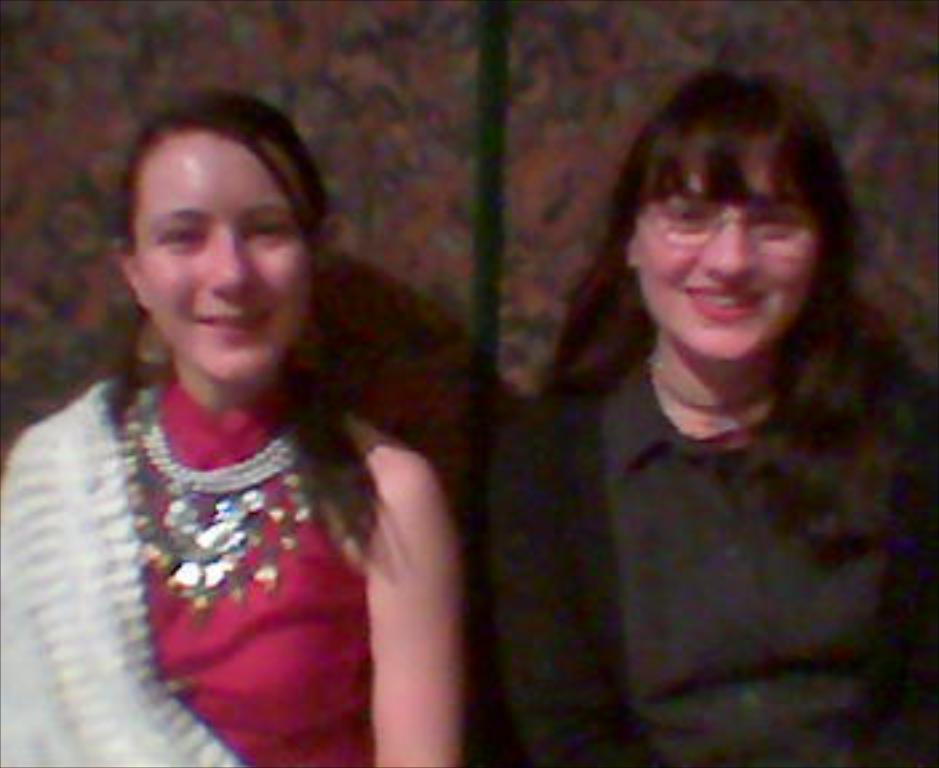How many people are in the image? There are two women in the image. What is the facial expression of the women? The women are smiling. Can you describe the background of the image? The background of the image is blurry. What type of vest is the woman on the left side of the image wearing? There is no vest visible in the image; both women are wearing dresses. 